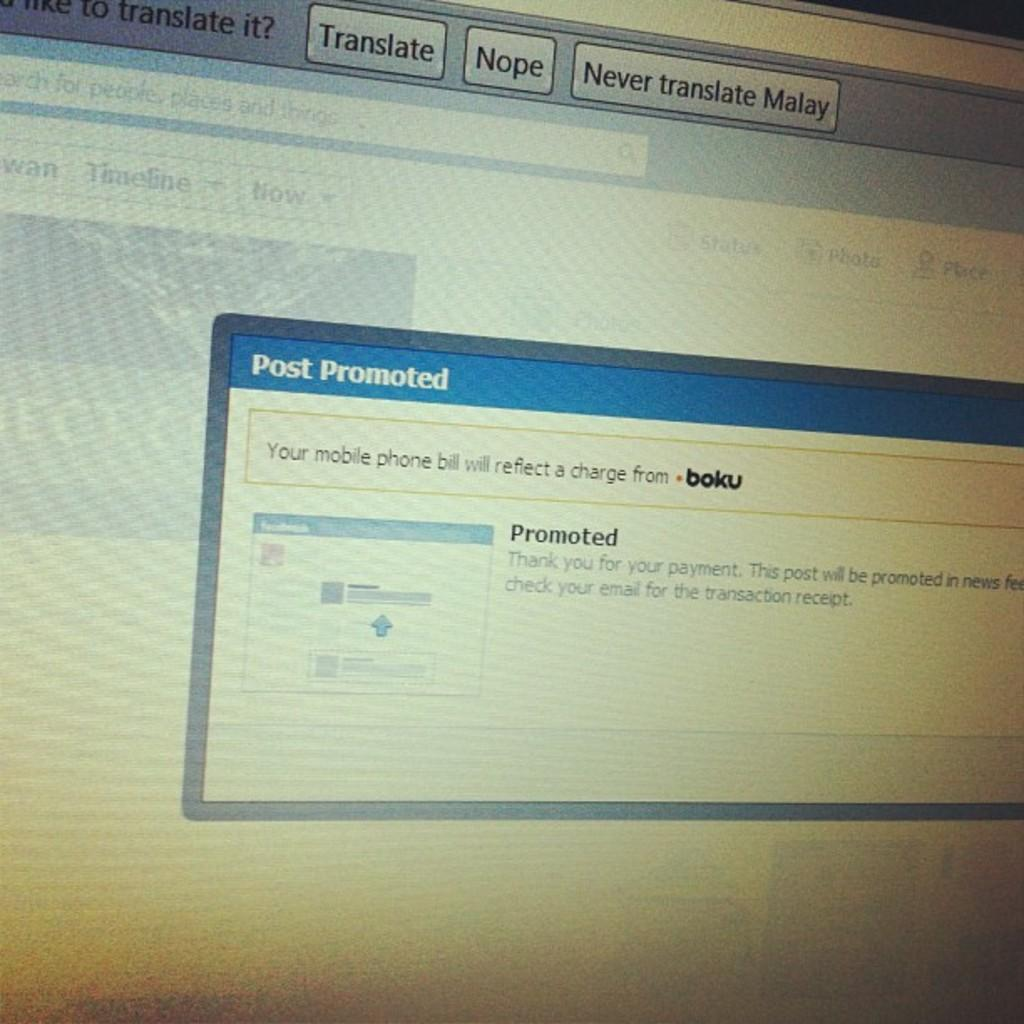<image>
Share a concise interpretation of the image provided. A screen gives an option to translate the Malay language. 